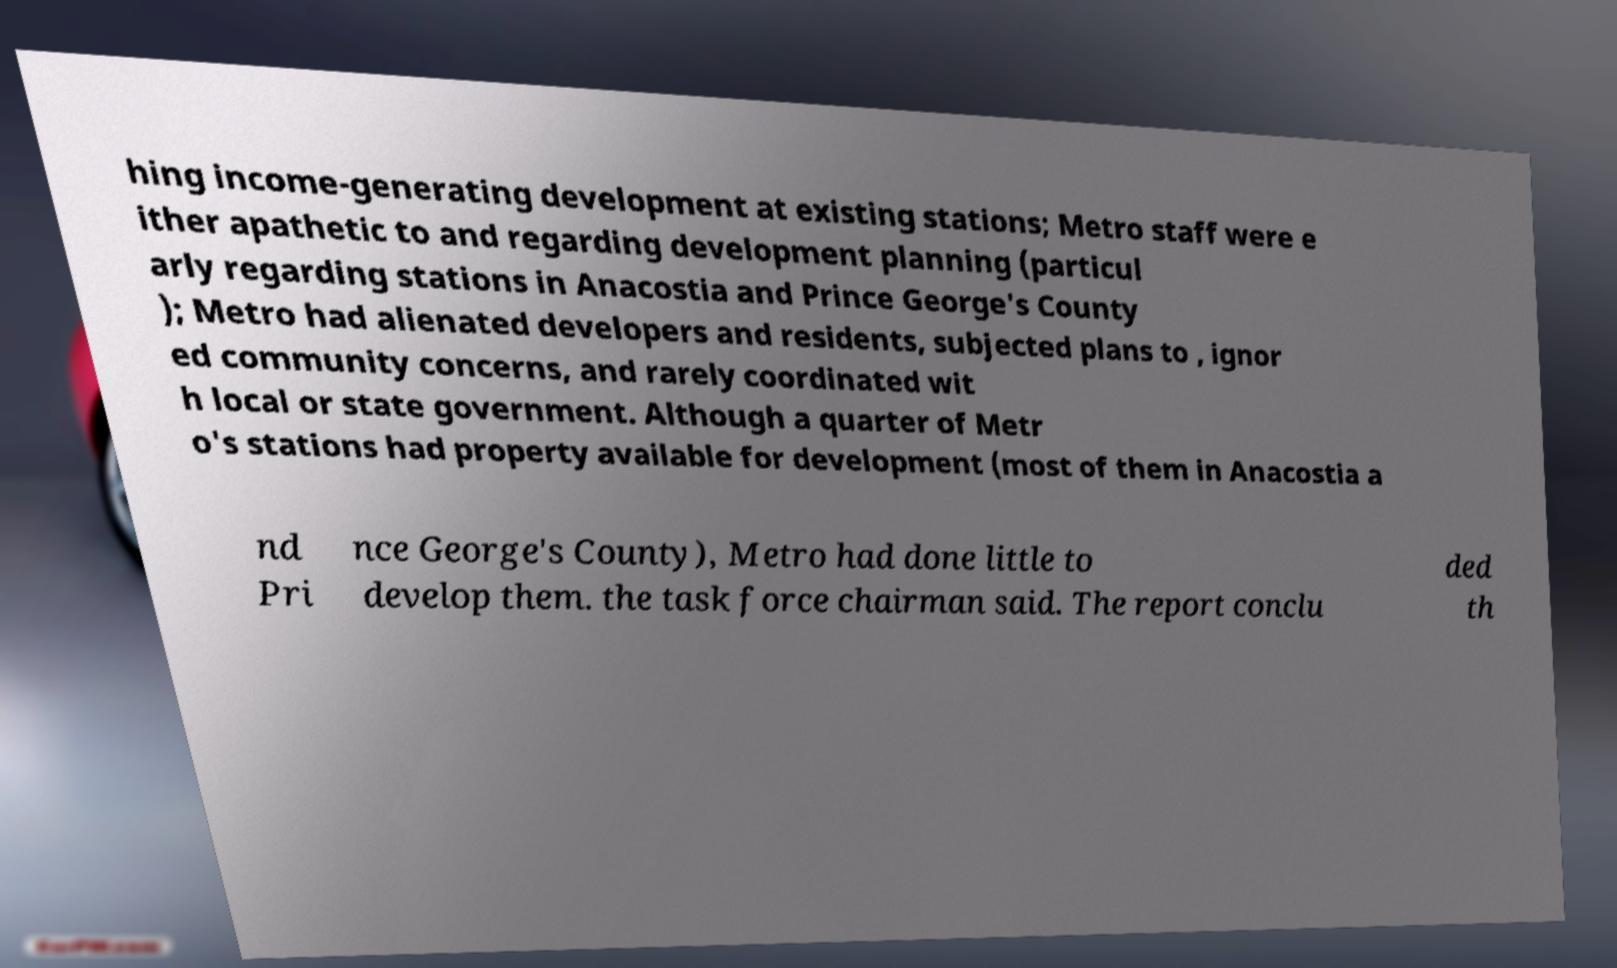Please identify and transcribe the text found in this image. hing income-generating development at existing stations; Metro staff were e ither apathetic to and regarding development planning (particul arly regarding stations in Anacostia and Prince George's County ); Metro had alienated developers and residents, subjected plans to , ignor ed community concerns, and rarely coordinated wit h local or state government. Although a quarter of Metr o's stations had property available for development (most of them in Anacostia a nd Pri nce George's County), Metro had done little to develop them. the task force chairman said. The report conclu ded th 